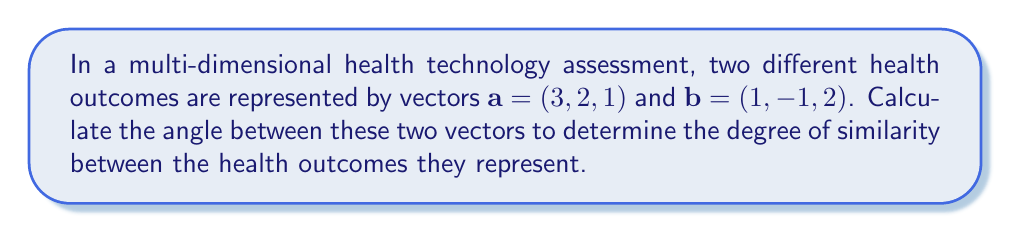Solve this math problem. To calculate the angle between two vectors, we can use the dot product formula:

$$\cos \theta = \frac{\mathbf{a} \cdot \mathbf{b}}{|\mathbf{a}||\mathbf{b}|}$$

Where $\mathbf{a} \cdot \mathbf{b}$ is the dot product of the vectors, and $|\mathbf{a}|$ and $|\mathbf{b}|$ are the magnitudes of vectors $\mathbf{a}$ and $\mathbf{b}$ respectively.

Step 1: Calculate the dot product $\mathbf{a} \cdot \mathbf{b}$
$$\mathbf{a} \cdot \mathbf{b} = (3)(1) + (2)(-1) + (1)(2) = 3 - 2 + 2 = 3$$

Step 2: Calculate the magnitudes of $\mathbf{a}$ and $\mathbf{b}$
$$|\mathbf{a}| = \sqrt{3^2 + 2^2 + 1^2} = \sqrt{14}$$
$$|\mathbf{b}| = \sqrt{1^2 + (-1)^2 + 2^2} = \sqrt{6}$$

Step 3: Apply the dot product formula
$$\cos \theta = \frac{3}{\sqrt{14}\sqrt{6}}$$

Step 4: Simplify
$$\cos \theta = \frac{3}{\sqrt{84}}$$

Step 5: Take the inverse cosine (arccos) of both sides
$$\theta = \arccos\left(\frac{3}{\sqrt{84}}\right)$$

Step 6: Calculate the result (in radians)
$$\theta \approx 1.2490$$

Step 7: Convert to degrees
$$\theta \approx 71.57°$$
Answer: The angle between the two vectors representing different health outcomes is approximately 71.57°. 